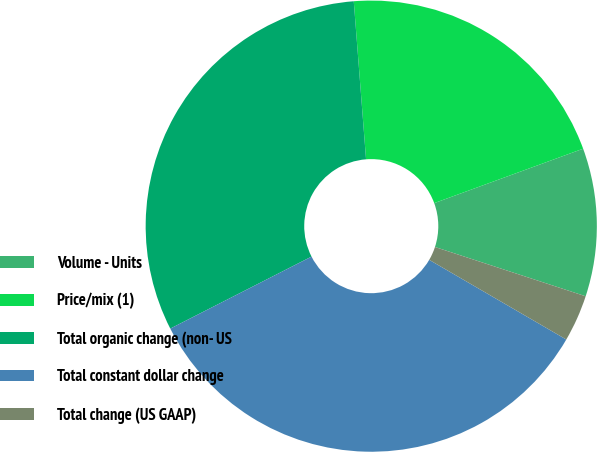Convert chart to OTSL. <chart><loc_0><loc_0><loc_500><loc_500><pie_chart><fcel>Volume - Units<fcel>Price/mix (1)<fcel>Total organic change (non- US<fcel>Total constant dollar change<fcel>Total change (US GAAP)<nl><fcel>10.61%<fcel>20.66%<fcel>31.27%<fcel>34.12%<fcel>3.35%<nl></chart> 